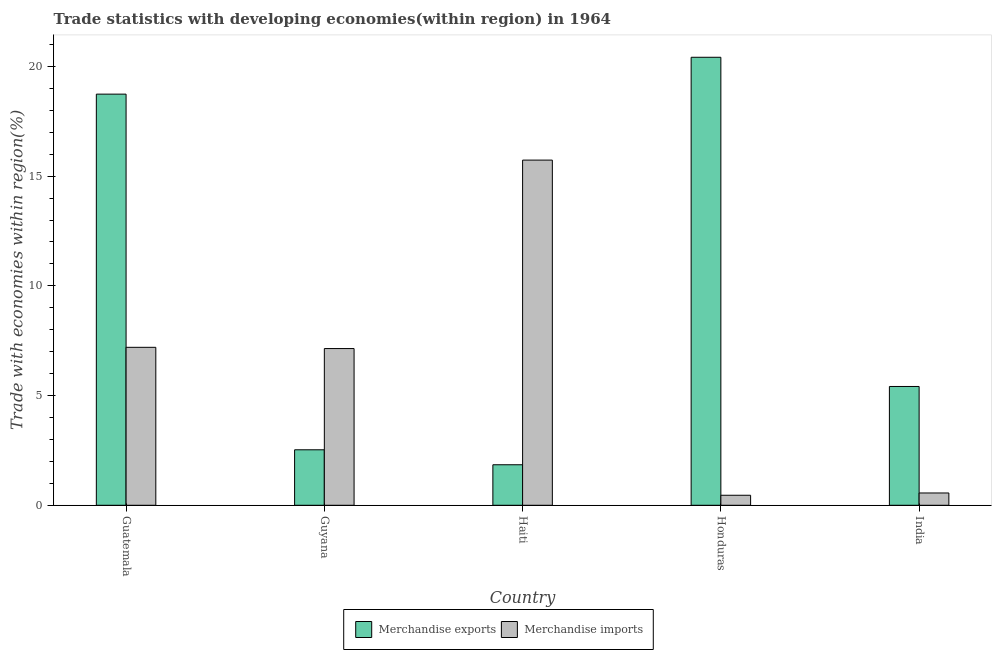How many different coloured bars are there?
Ensure brevity in your answer.  2. Are the number of bars per tick equal to the number of legend labels?
Your answer should be very brief. Yes. Are the number of bars on each tick of the X-axis equal?
Make the answer very short. Yes. What is the label of the 4th group of bars from the left?
Offer a very short reply. Honduras. What is the merchandise exports in Haiti?
Offer a terse response. 1.85. Across all countries, what is the maximum merchandise imports?
Your answer should be very brief. 15.73. Across all countries, what is the minimum merchandise imports?
Provide a succinct answer. 0.46. In which country was the merchandise imports maximum?
Your response must be concise. Haiti. In which country was the merchandise imports minimum?
Your answer should be compact. Honduras. What is the total merchandise imports in the graph?
Give a very brief answer. 31.09. What is the difference between the merchandise imports in Honduras and that in India?
Ensure brevity in your answer.  -0.1. What is the difference between the merchandise exports in Haiti and the merchandise imports in Guatemala?
Your answer should be compact. -5.35. What is the average merchandise imports per country?
Give a very brief answer. 6.22. What is the difference between the merchandise imports and merchandise exports in Haiti?
Your answer should be very brief. 13.89. In how many countries, is the merchandise imports greater than 3 %?
Ensure brevity in your answer.  3. What is the ratio of the merchandise imports in Haiti to that in India?
Give a very brief answer. 28.08. Is the merchandise exports in Guatemala less than that in India?
Provide a short and direct response. No. Is the difference between the merchandise exports in Guyana and Haiti greater than the difference between the merchandise imports in Guyana and Haiti?
Offer a terse response. Yes. What is the difference between the highest and the second highest merchandise exports?
Make the answer very short. 1.68. What is the difference between the highest and the lowest merchandise imports?
Your answer should be compact. 15.28. In how many countries, is the merchandise exports greater than the average merchandise exports taken over all countries?
Provide a short and direct response. 2. What does the 1st bar from the left in Guyana represents?
Provide a short and direct response. Merchandise exports. What does the 2nd bar from the right in Guatemala represents?
Your response must be concise. Merchandise exports. How many bars are there?
Your answer should be compact. 10. Are all the bars in the graph horizontal?
Your answer should be very brief. No. What is the difference between two consecutive major ticks on the Y-axis?
Your answer should be very brief. 5. Does the graph contain any zero values?
Provide a short and direct response. No. Does the graph contain grids?
Your answer should be compact. No. Where does the legend appear in the graph?
Provide a succinct answer. Bottom center. How are the legend labels stacked?
Ensure brevity in your answer.  Horizontal. What is the title of the graph?
Ensure brevity in your answer.  Trade statistics with developing economies(within region) in 1964. What is the label or title of the X-axis?
Your answer should be compact. Country. What is the label or title of the Y-axis?
Give a very brief answer. Trade with economies within region(%). What is the Trade with economies within region(%) in Merchandise exports in Guatemala?
Your answer should be very brief. 18.74. What is the Trade with economies within region(%) of Merchandise imports in Guatemala?
Give a very brief answer. 7.2. What is the Trade with economies within region(%) of Merchandise exports in Guyana?
Your answer should be very brief. 2.53. What is the Trade with economies within region(%) in Merchandise imports in Guyana?
Keep it short and to the point. 7.14. What is the Trade with economies within region(%) of Merchandise exports in Haiti?
Offer a terse response. 1.85. What is the Trade with economies within region(%) of Merchandise imports in Haiti?
Ensure brevity in your answer.  15.73. What is the Trade with economies within region(%) of Merchandise exports in Honduras?
Offer a terse response. 20.42. What is the Trade with economies within region(%) of Merchandise imports in Honduras?
Your response must be concise. 0.46. What is the Trade with economies within region(%) in Merchandise exports in India?
Keep it short and to the point. 5.41. What is the Trade with economies within region(%) of Merchandise imports in India?
Provide a short and direct response. 0.56. Across all countries, what is the maximum Trade with economies within region(%) of Merchandise exports?
Your answer should be compact. 20.42. Across all countries, what is the maximum Trade with economies within region(%) in Merchandise imports?
Offer a very short reply. 15.73. Across all countries, what is the minimum Trade with economies within region(%) in Merchandise exports?
Your answer should be compact. 1.85. Across all countries, what is the minimum Trade with economies within region(%) of Merchandise imports?
Provide a succinct answer. 0.46. What is the total Trade with economies within region(%) of Merchandise exports in the graph?
Offer a terse response. 48.95. What is the total Trade with economies within region(%) in Merchandise imports in the graph?
Make the answer very short. 31.09. What is the difference between the Trade with economies within region(%) in Merchandise exports in Guatemala and that in Guyana?
Your answer should be compact. 16.21. What is the difference between the Trade with economies within region(%) in Merchandise imports in Guatemala and that in Guyana?
Provide a short and direct response. 0.06. What is the difference between the Trade with economies within region(%) of Merchandise exports in Guatemala and that in Haiti?
Provide a succinct answer. 16.89. What is the difference between the Trade with economies within region(%) in Merchandise imports in Guatemala and that in Haiti?
Provide a short and direct response. -8.53. What is the difference between the Trade with economies within region(%) in Merchandise exports in Guatemala and that in Honduras?
Make the answer very short. -1.68. What is the difference between the Trade with economies within region(%) of Merchandise imports in Guatemala and that in Honduras?
Keep it short and to the point. 6.74. What is the difference between the Trade with economies within region(%) of Merchandise exports in Guatemala and that in India?
Make the answer very short. 13.32. What is the difference between the Trade with economies within region(%) of Merchandise imports in Guatemala and that in India?
Provide a short and direct response. 6.64. What is the difference between the Trade with economies within region(%) of Merchandise exports in Guyana and that in Haiti?
Your answer should be very brief. 0.68. What is the difference between the Trade with economies within region(%) in Merchandise imports in Guyana and that in Haiti?
Offer a very short reply. -8.59. What is the difference between the Trade with economies within region(%) of Merchandise exports in Guyana and that in Honduras?
Ensure brevity in your answer.  -17.89. What is the difference between the Trade with economies within region(%) in Merchandise imports in Guyana and that in Honduras?
Make the answer very short. 6.69. What is the difference between the Trade with economies within region(%) in Merchandise exports in Guyana and that in India?
Your answer should be compact. -2.89. What is the difference between the Trade with economies within region(%) of Merchandise imports in Guyana and that in India?
Provide a succinct answer. 6.58. What is the difference between the Trade with economies within region(%) in Merchandise exports in Haiti and that in Honduras?
Make the answer very short. -18.57. What is the difference between the Trade with economies within region(%) in Merchandise imports in Haiti and that in Honduras?
Ensure brevity in your answer.  15.28. What is the difference between the Trade with economies within region(%) of Merchandise exports in Haiti and that in India?
Offer a very short reply. -3.57. What is the difference between the Trade with economies within region(%) of Merchandise imports in Haiti and that in India?
Make the answer very short. 15.17. What is the difference between the Trade with economies within region(%) in Merchandise exports in Honduras and that in India?
Offer a terse response. 15. What is the difference between the Trade with economies within region(%) of Merchandise imports in Honduras and that in India?
Make the answer very short. -0.1. What is the difference between the Trade with economies within region(%) in Merchandise exports in Guatemala and the Trade with economies within region(%) in Merchandise imports in Guyana?
Provide a short and direct response. 11.6. What is the difference between the Trade with economies within region(%) of Merchandise exports in Guatemala and the Trade with economies within region(%) of Merchandise imports in Haiti?
Your answer should be very brief. 3.01. What is the difference between the Trade with economies within region(%) in Merchandise exports in Guatemala and the Trade with economies within region(%) in Merchandise imports in Honduras?
Offer a very short reply. 18.28. What is the difference between the Trade with economies within region(%) of Merchandise exports in Guatemala and the Trade with economies within region(%) of Merchandise imports in India?
Keep it short and to the point. 18.18. What is the difference between the Trade with economies within region(%) in Merchandise exports in Guyana and the Trade with economies within region(%) in Merchandise imports in Haiti?
Give a very brief answer. -13.2. What is the difference between the Trade with economies within region(%) of Merchandise exports in Guyana and the Trade with economies within region(%) of Merchandise imports in Honduras?
Provide a succinct answer. 2.07. What is the difference between the Trade with economies within region(%) of Merchandise exports in Guyana and the Trade with economies within region(%) of Merchandise imports in India?
Offer a very short reply. 1.97. What is the difference between the Trade with economies within region(%) of Merchandise exports in Haiti and the Trade with economies within region(%) of Merchandise imports in Honduras?
Your answer should be very brief. 1.39. What is the difference between the Trade with economies within region(%) in Merchandise exports in Haiti and the Trade with economies within region(%) in Merchandise imports in India?
Ensure brevity in your answer.  1.29. What is the difference between the Trade with economies within region(%) of Merchandise exports in Honduras and the Trade with economies within region(%) of Merchandise imports in India?
Offer a very short reply. 19.86. What is the average Trade with economies within region(%) in Merchandise exports per country?
Provide a short and direct response. 9.79. What is the average Trade with economies within region(%) of Merchandise imports per country?
Provide a succinct answer. 6.22. What is the difference between the Trade with economies within region(%) in Merchandise exports and Trade with economies within region(%) in Merchandise imports in Guatemala?
Offer a terse response. 11.54. What is the difference between the Trade with economies within region(%) in Merchandise exports and Trade with economies within region(%) in Merchandise imports in Guyana?
Your answer should be compact. -4.61. What is the difference between the Trade with economies within region(%) of Merchandise exports and Trade with economies within region(%) of Merchandise imports in Haiti?
Offer a very short reply. -13.88. What is the difference between the Trade with economies within region(%) of Merchandise exports and Trade with economies within region(%) of Merchandise imports in Honduras?
Provide a succinct answer. 19.96. What is the difference between the Trade with economies within region(%) in Merchandise exports and Trade with economies within region(%) in Merchandise imports in India?
Provide a short and direct response. 4.85. What is the ratio of the Trade with economies within region(%) of Merchandise exports in Guatemala to that in Guyana?
Give a very brief answer. 7.41. What is the ratio of the Trade with economies within region(%) in Merchandise imports in Guatemala to that in Guyana?
Provide a succinct answer. 1.01. What is the ratio of the Trade with economies within region(%) in Merchandise exports in Guatemala to that in Haiti?
Provide a short and direct response. 10.15. What is the ratio of the Trade with economies within region(%) in Merchandise imports in Guatemala to that in Haiti?
Provide a succinct answer. 0.46. What is the ratio of the Trade with economies within region(%) of Merchandise exports in Guatemala to that in Honduras?
Give a very brief answer. 0.92. What is the ratio of the Trade with economies within region(%) in Merchandise imports in Guatemala to that in Honduras?
Your response must be concise. 15.77. What is the ratio of the Trade with economies within region(%) in Merchandise exports in Guatemala to that in India?
Offer a very short reply. 3.46. What is the ratio of the Trade with economies within region(%) in Merchandise imports in Guatemala to that in India?
Ensure brevity in your answer.  12.85. What is the ratio of the Trade with economies within region(%) in Merchandise exports in Guyana to that in Haiti?
Your answer should be very brief. 1.37. What is the ratio of the Trade with economies within region(%) of Merchandise imports in Guyana to that in Haiti?
Your answer should be compact. 0.45. What is the ratio of the Trade with economies within region(%) of Merchandise exports in Guyana to that in Honduras?
Keep it short and to the point. 0.12. What is the ratio of the Trade with economies within region(%) in Merchandise imports in Guyana to that in Honduras?
Your answer should be compact. 15.64. What is the ratio of the Trade with economies within region(%) of Merchandise exports in Guyana to that in India?
Provide a succinct answer. 0.47. What is the ratio of the Trade with economies within region(%) of Merchandise imports in Guyana to that in India?
Make the answer very short. 12.75. What is the ratio of the Trade with economies within region(%) of Merchandise exports in Haiti to that in Honduras?
Make the answer very short. 0.09. What is the ratio of the Trade with economies within region(%) of Merchandise imports in Haiti to that in Honduras?
Provide a short and direct response. 34.45. What is the ratio of the Trade with economies within region(%) in Merchandise exports in Haiti to that in India?
Offer a terse response. 0.34. What is the ratio of the Trade with economies within region(%) in Merchandise imports in Haiti to that in India?
Ensure brevity in your answer.  28.08. What is the ratio of the Trade with economies within region(%) of Merchandise exports in Honduras to that in India?
Your answer should be very brief. 3.77. What is the ratio of the Trade with economies within region(%) of Merchandise imports in Honduras to that in India?
Your answer should be compact. 0.82. What is the difference between the highest and the second highest Trade with economies within region(%) of Merchandise exports?
Keep it short and to the point. 1.68. What is the difference between the highest and the second highest Trade with economies within region(%) in Merchandise imports?
Provide a succinct answer. 8.53. What is the difference between the highest and the lowest Trade with economies within region(%) of Merchandise exports?
Your answer should be compact. 18.57. What is the difference between the highest and the lowest Trade with economies within region(%) of Merchandise imports?
Offer a terse response. 15.28. 